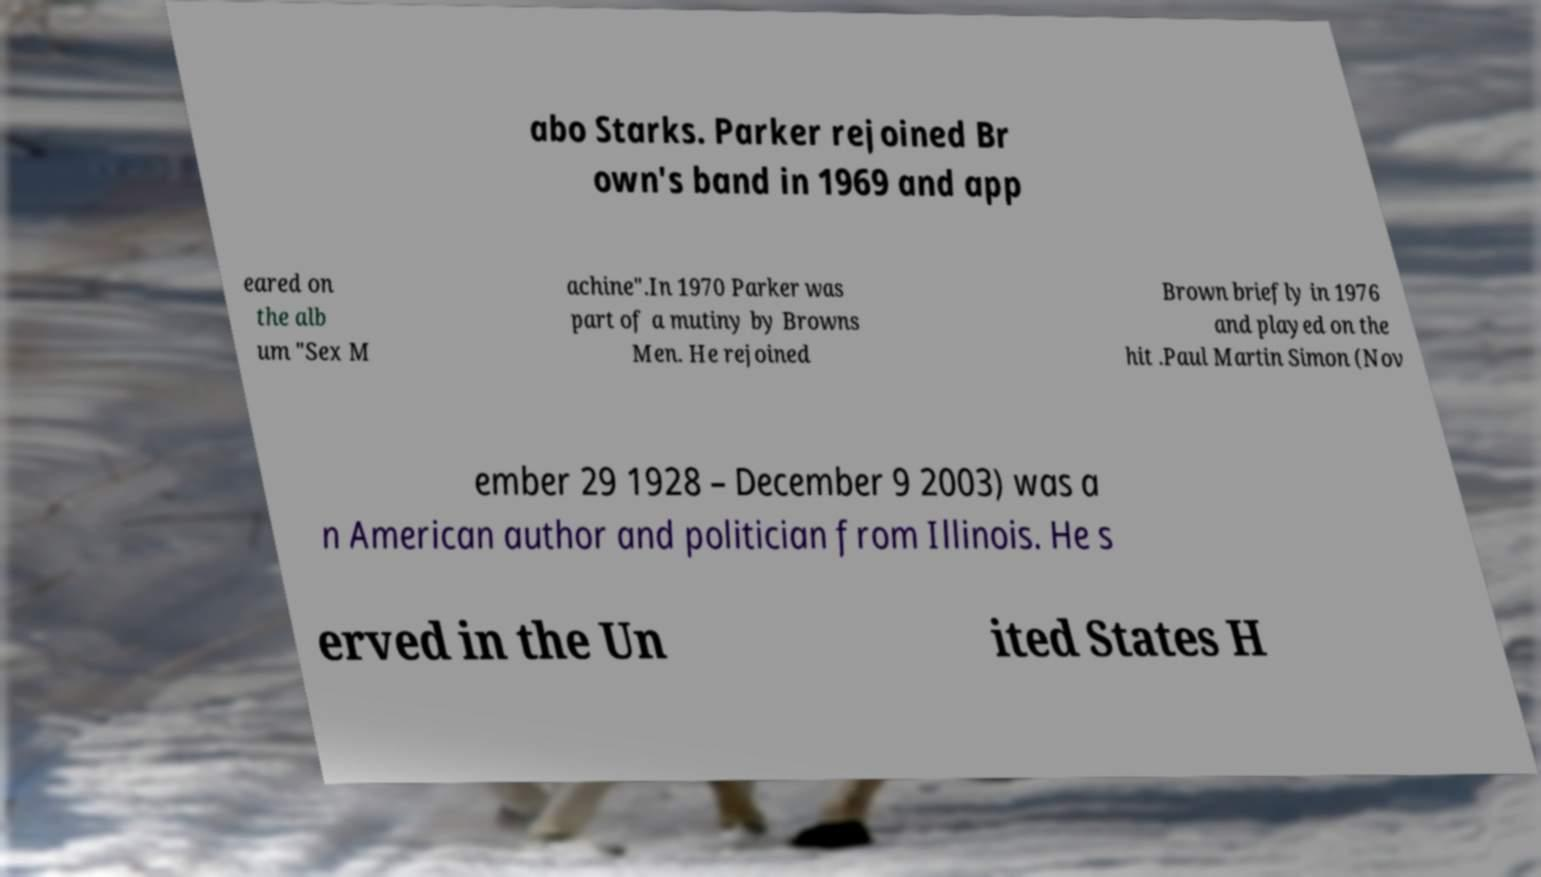Can you read and provide the text displayed in the image?This photo seems to have some interesting text. Can you extract and type it out for me? abo Starks. Parker rejoined Br own's band in 1969 and app eared on the alb um "Sex M achine".In 1970 Parker was part of a mutiny by Browns Men. He rejoined Brown briefly in 1976 and played on the hit .Paul Martin Simon (Nov ember 29 1928 – December 9 2003) was a n American author and politician from Illinois. He s erved in the Un ited States H 